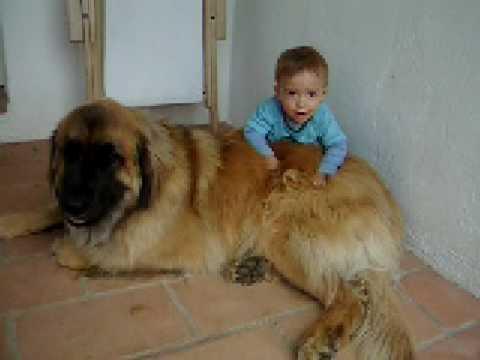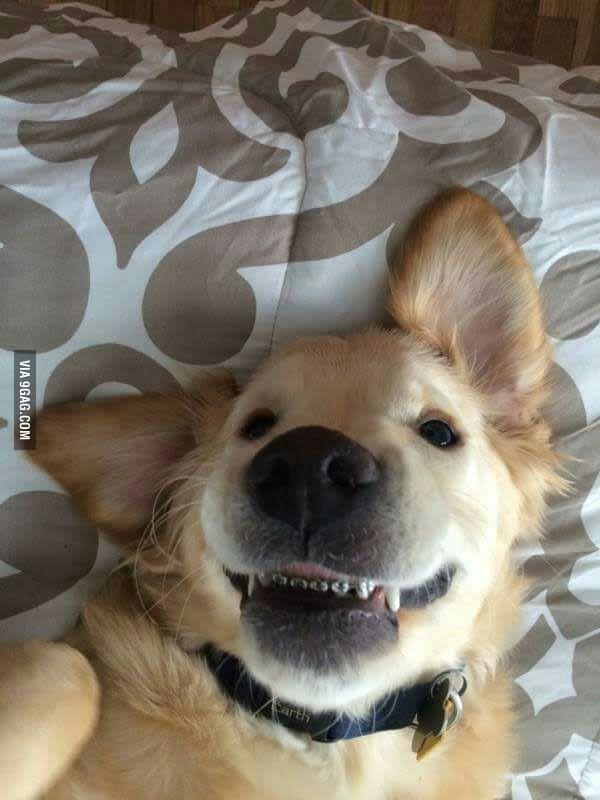The first image is the image on the left, the second image is the image on the right. Assess this claim about the two images: "There is a human in the image on the right.". Correct or not? Answer yes or no. No. 